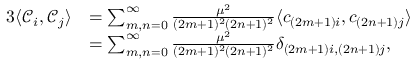<formula> <loc_0><loc_0><loc_500><loc_500>\begin{array} { r l } { 3 \langle { { \mathcal { C } } _ { i } } , { { \mathcal { C } } _ { j } } \rangle } & { = \sum _ { m , n = 0 } ^ { \infty } \frac { \mu ^ { 2 } } { ( 2 m + 1 ) ^ { 2 } ( 2 n + 1 ) ^ { 2 } } \langle c _ { ( 2 m + 1 ) i } , c _ { ( 2 n + 1 ) j } \rangle } \\ & { = \sum _ { m , n = 0 } ^ { \infty } \frac { \mu ^ { 2 } } { ( 2 m + 1 ) ^ { 2 } ( 2 n + 1 ) ^ { 2 } } \delta _ { ( 2 m + 1 ) i , ( 2 n + 1 ) j } , } \end{array}</formula> 